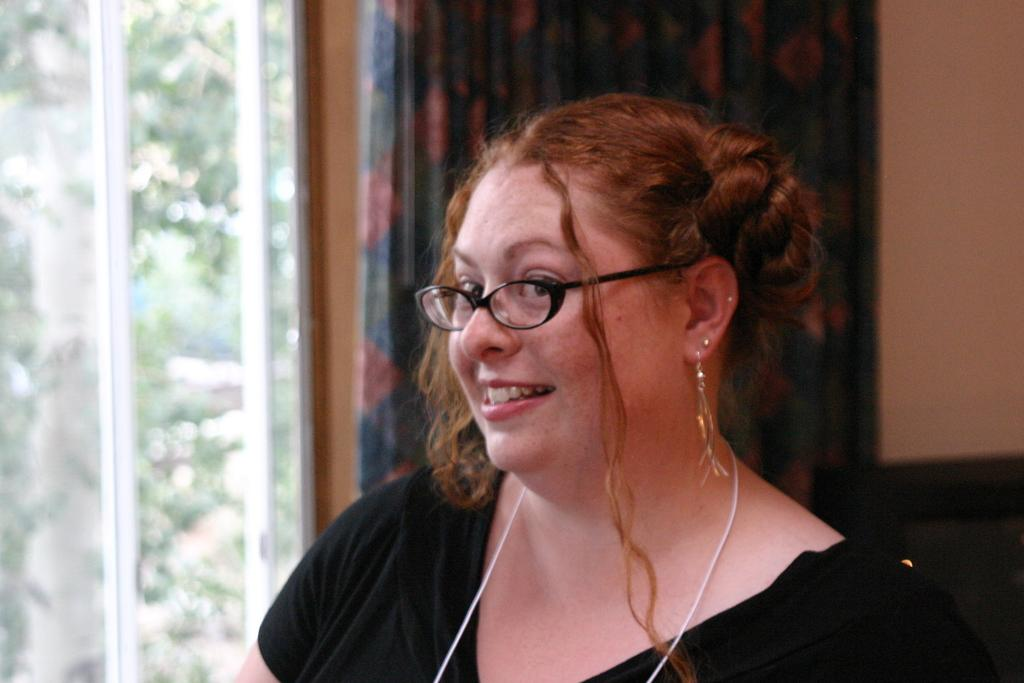Who is present in the image? There is a woman in the image. What is the woman wearing on her face? The woman is wearing spectacles. What is the woman's facial expression? The woman is smiling. What can be seen in the background of the image? There is a curtain, a window, and a wall in the background of the image. What type of acoustics can be heard in the image? There is no sound or acoustics present in the image, as it is a still photograph. Is the woman wearing a scarf in the image? No, the woman is not wearing a scarf in the image; she is wearing spectacles. 